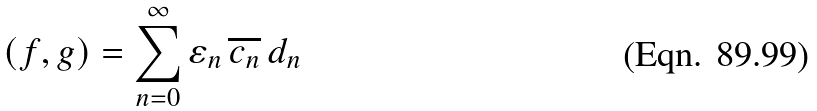Convert formula to latex. <formula><loc_0><loc_0><loc_500><loc_500>( f , g ) = \sum _ { n = 0 } ^ { \infty } \varepsilon _ { n } \, \overline { c _ { n } } \, d _ { n }</formula> 